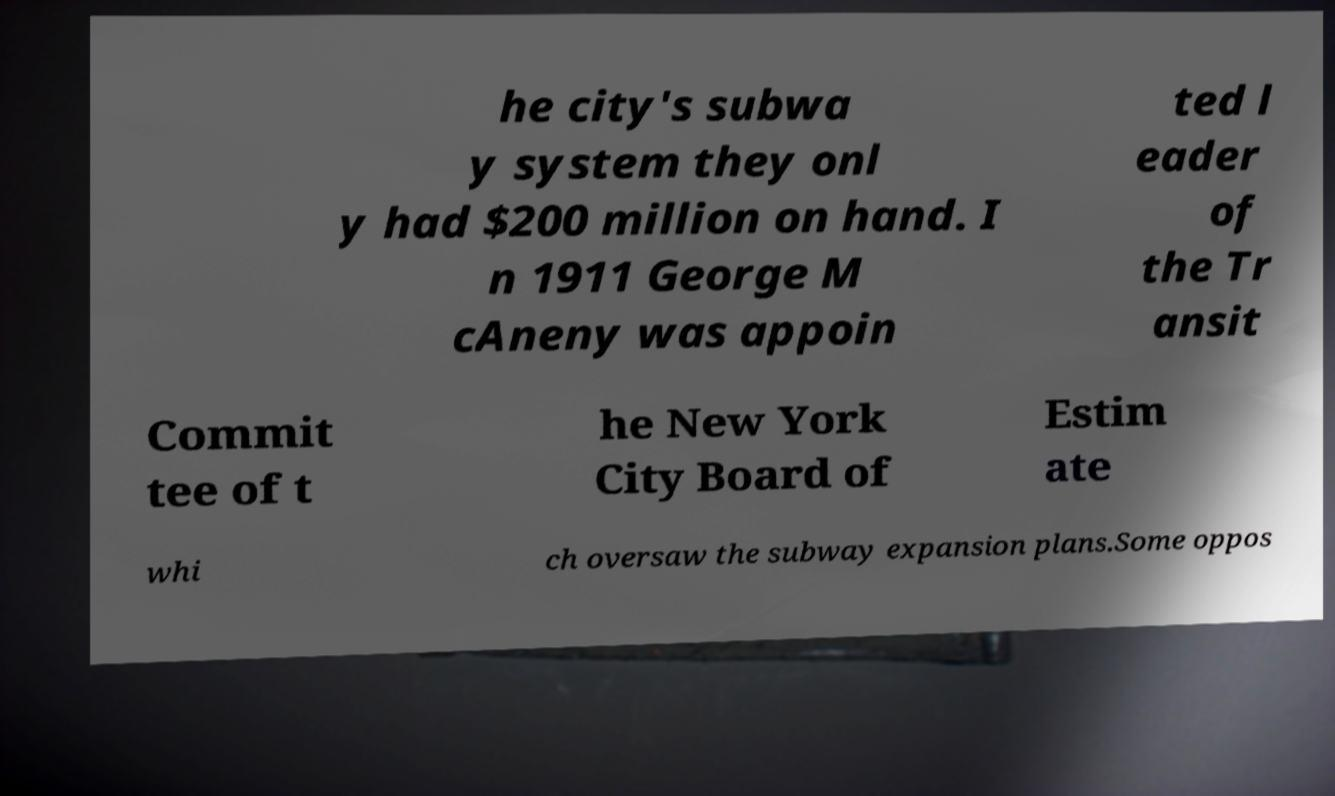For documentation purposes, I need the text within this image transcribed. Could you provide that? he city's subwa y system they onl y had $200 million on hand. I n 1911 George M cAneny was appoin ted l eader of the Tr ansit Commit tee of t he New York City Board of Estim ate whi ch oversaw the subway expansion plans.Some oppos 